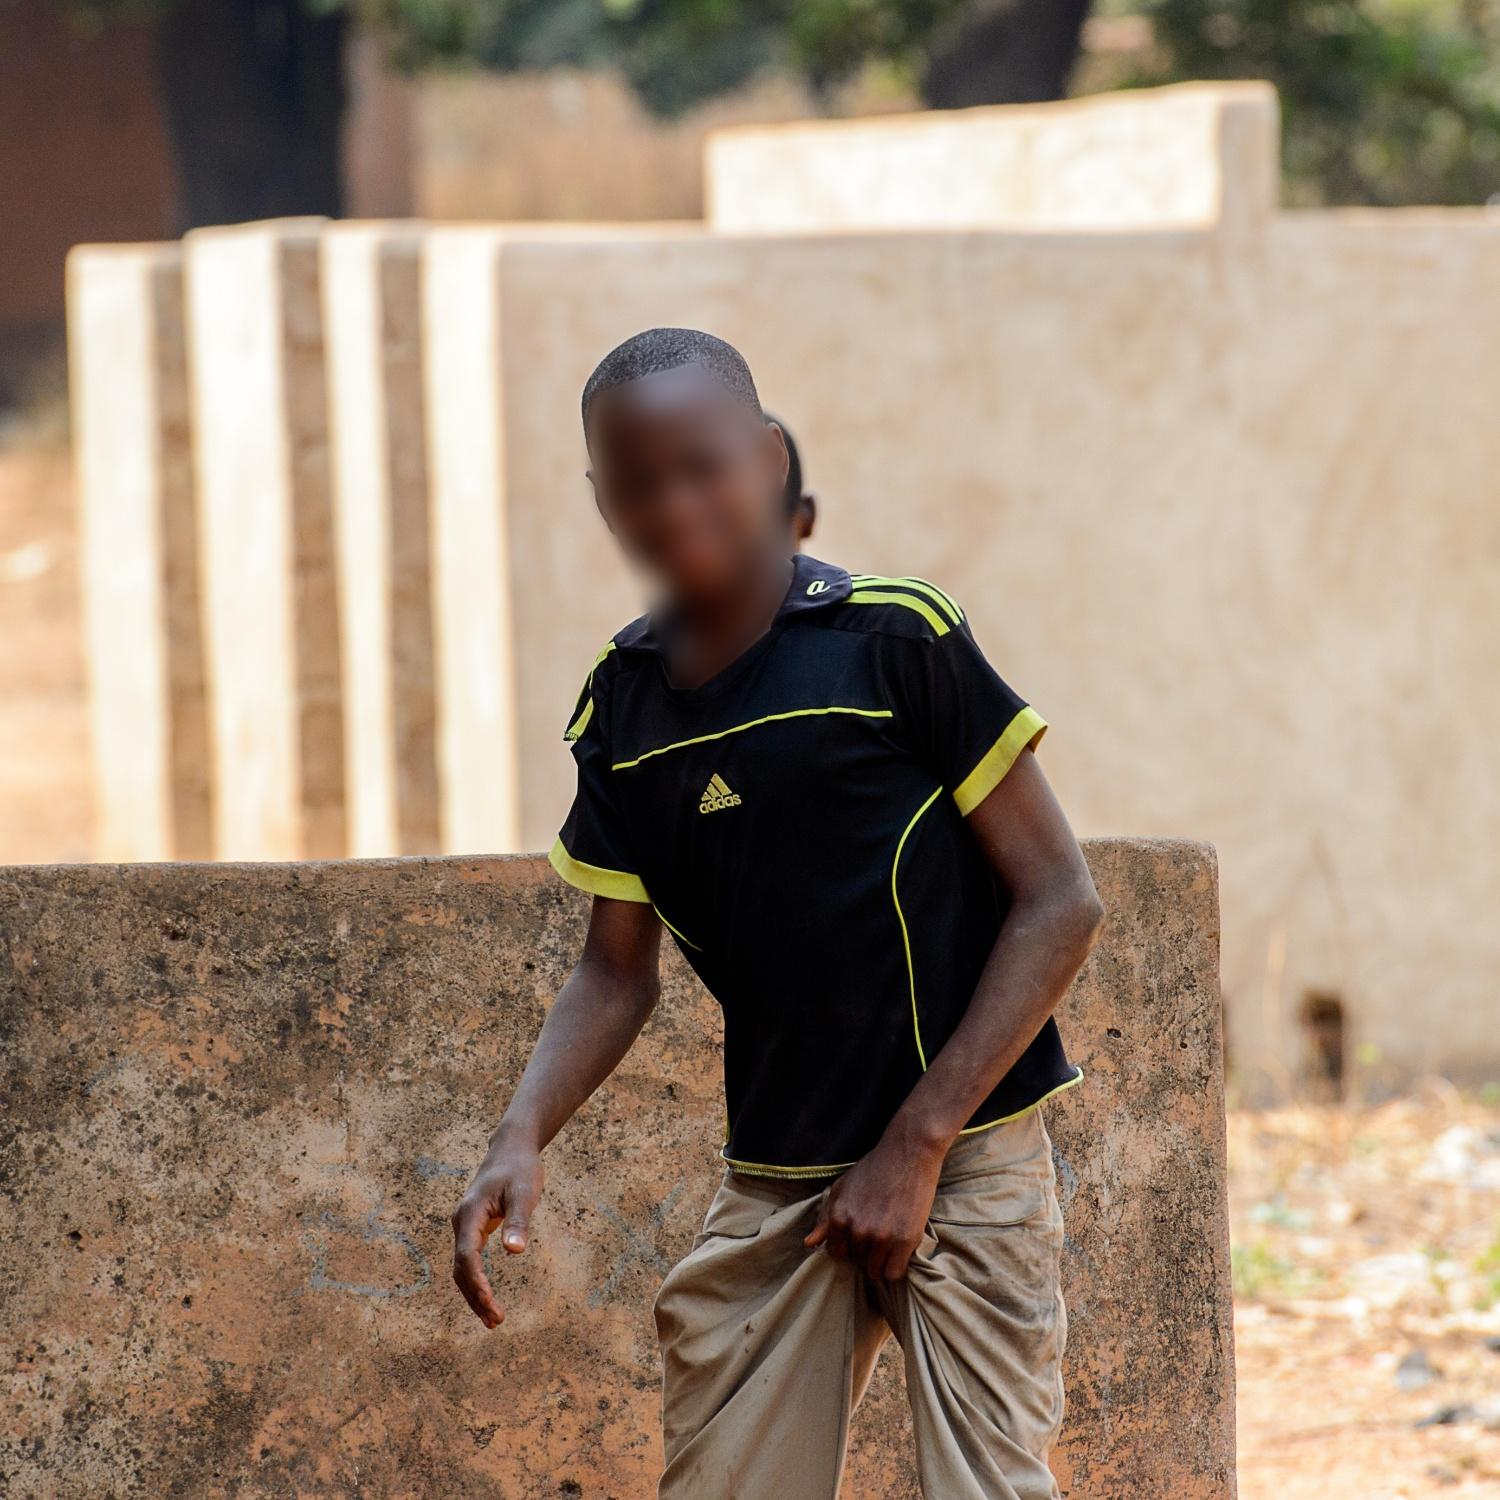What imaginative backstory could the boy have? In a village tucked away from the hustle of the world, the boy spent his early years trailing behind his father, a builder who crafted homes and walls like those in the image. As he grew older, tales from his grandmother about the village’s history filled his nights. She would tell him of a hidden legacy buried beneath the very ground he played on—artifacts and treasures from an ancient civilization once thriving there. The black and yellow Adidas shirt, a gift from an uncle who worked in the city, was his most prized possession, so much so that he wore it on his daily 'expeditions.' He believed that the shirt, bright and bold, endowed him with the courage of an explorer. Every day, he would map the walls and hidden routes, dreaming of uncovering secrets that awaited beneath their surface. In his heart, he carried the spirit of discovery, each line on the wall a map, each stone a clue, driven by the thrill of what might lie beneath the next wall. 